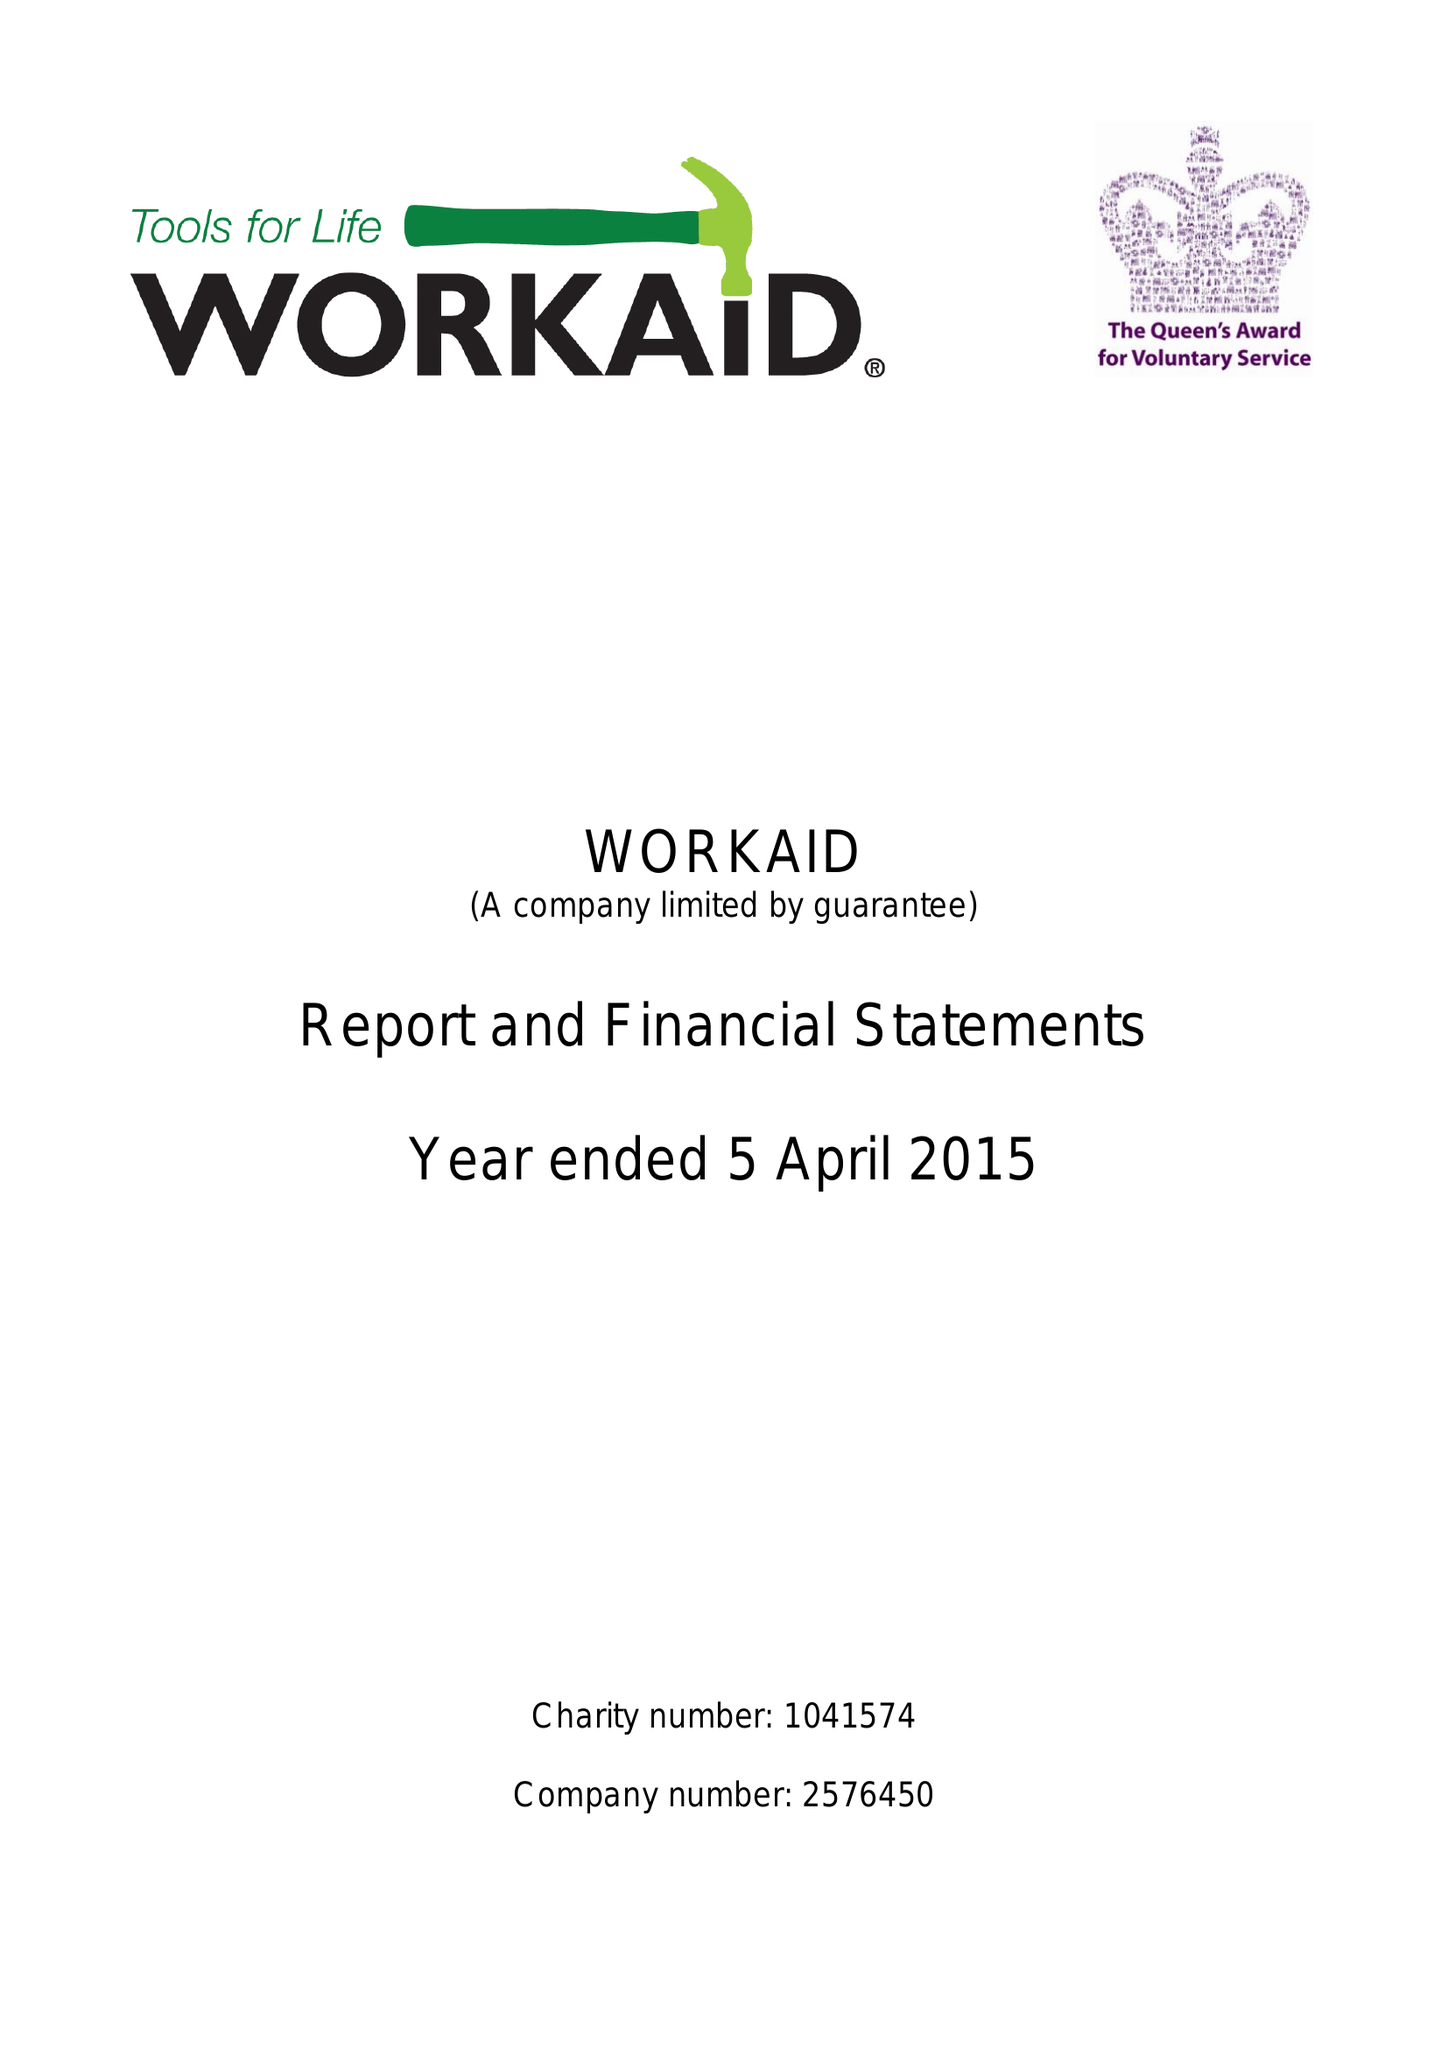What is the value for the charity_number?
Answer the question using a single word or phrase. 1041574 